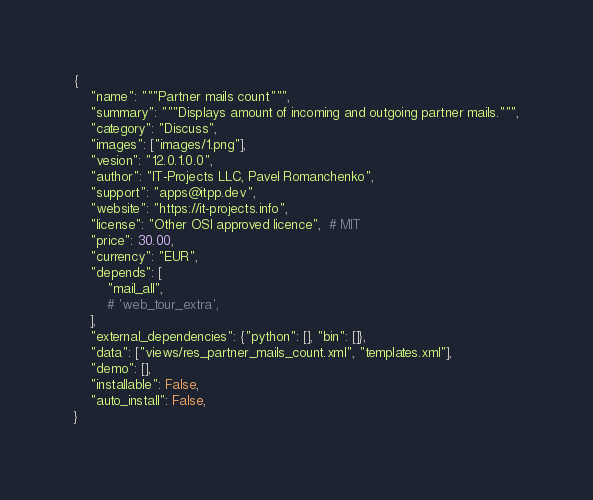Convert code to text. <code><loc_0><loc_0><loc_500><loc_500><_Python_>{
    "name": """Partner mails count""",
    "summary": """Displays amount of incoming and outgoing partner mails.""",
    "category": "Discuss",
    "images": ["images/1.png"],
    "vesion": "12.0.1.0.0",
    "author": "IT-Projects LLC, Pavel Romanchenko",
    "support": "apps@itpp.dev",
    "website": "https://it-projects.info",
    "license": "Other OSI approved licence",  # MIT
    "price": 30.00,
    "currency": "EUR",
    "depends": [
        "mail_all",
        # 'web_tour_extra',
    ],
    "external_dependencies": {"python": [], "bin": []},
    "data": ["views/res_partner_mails_count.xml", "templates.xml"],
    "demo": [],
    "installable": False,
    "auto_install": False,
}
</code> 